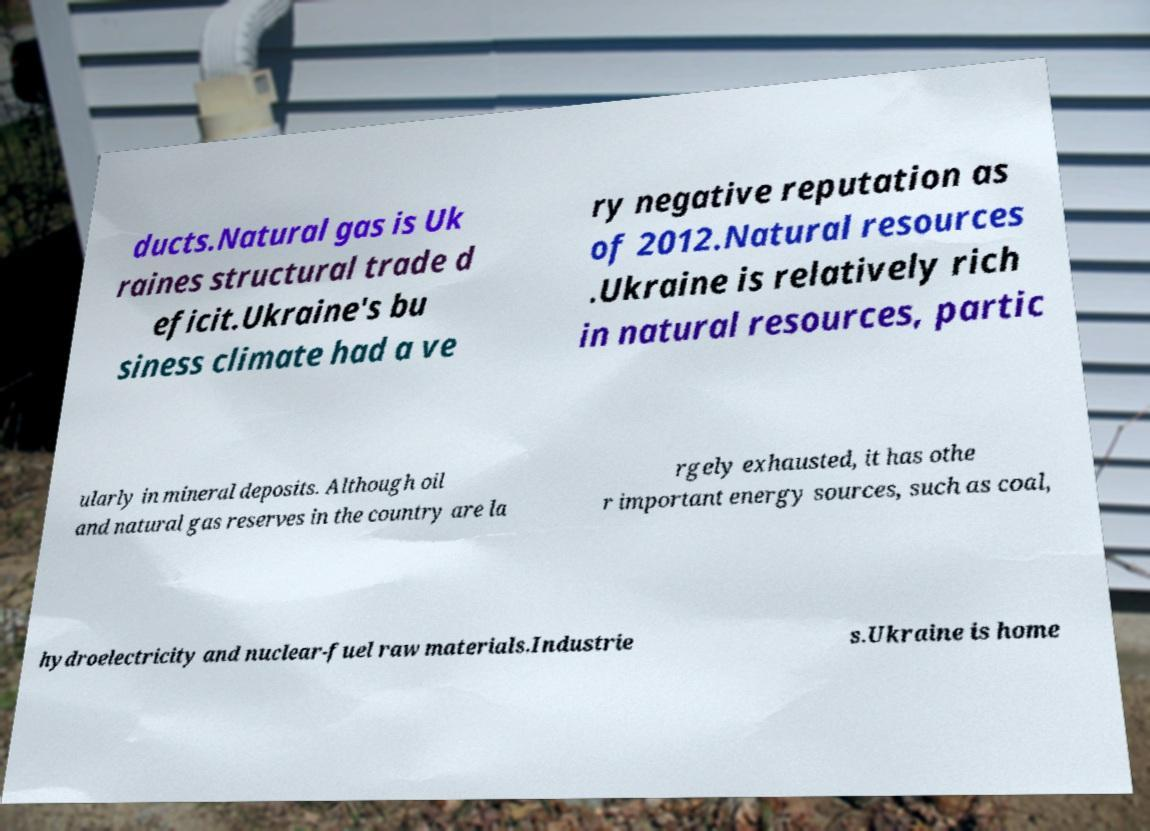For documentation purposes, I need the text within this image transcribed. Could you provide that? ducts.Natural gas is Uk raines structural trade d eficit.Ukraine's bu siness climate had a ve ry negative reputation as of 2012.Natural resources .Ukraine is relatively rich in natural resources, partic ularly in mineral deposits. Although oil and natural gas reserves in the country are la rgely exhausted, it has othe r important energy sources, such as coal, hydroelectricity and nuclear-fuel raw materials.Industrie s.Ukraine is home 